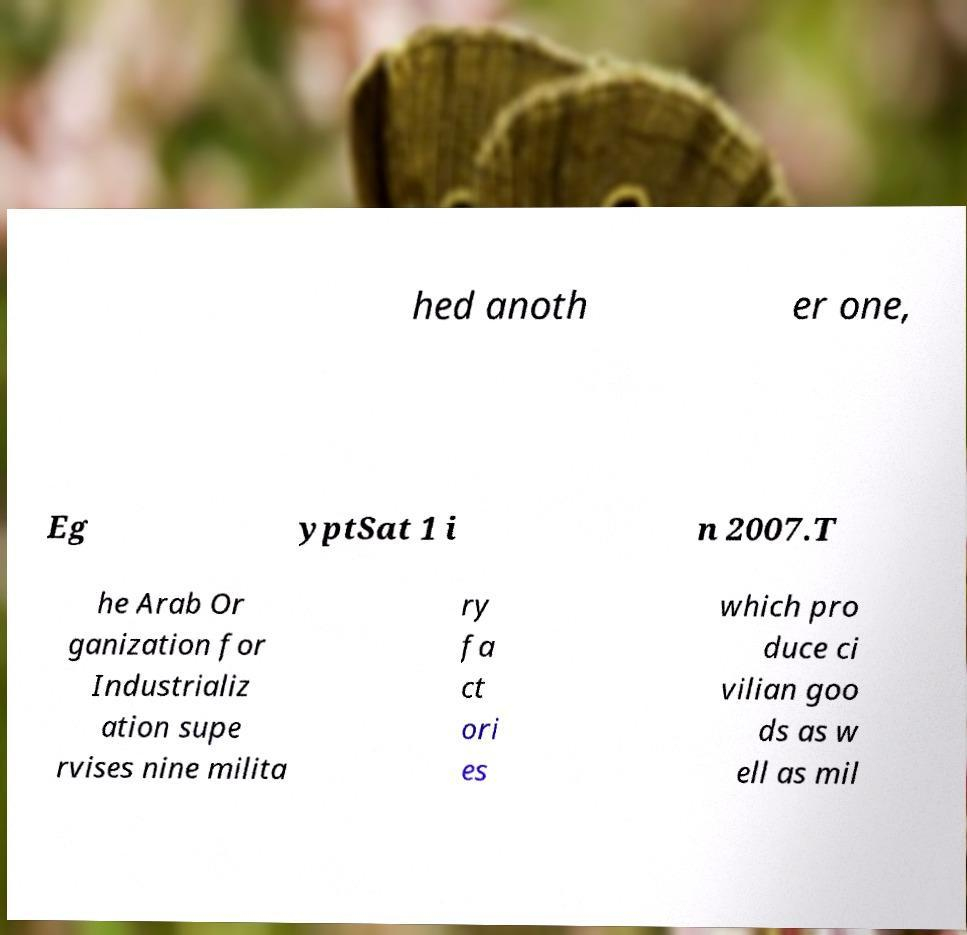There's text embedded in this image that I need extracted. Can you transcribe it verbatim? hed anoth er one, Eg yptSat 1 i n 2007.T he Arab Or ganization for Industrializ ation supe rvises nine milita ry fa ct ori es which pro duce ci vilian goo ds as w ell as mil 